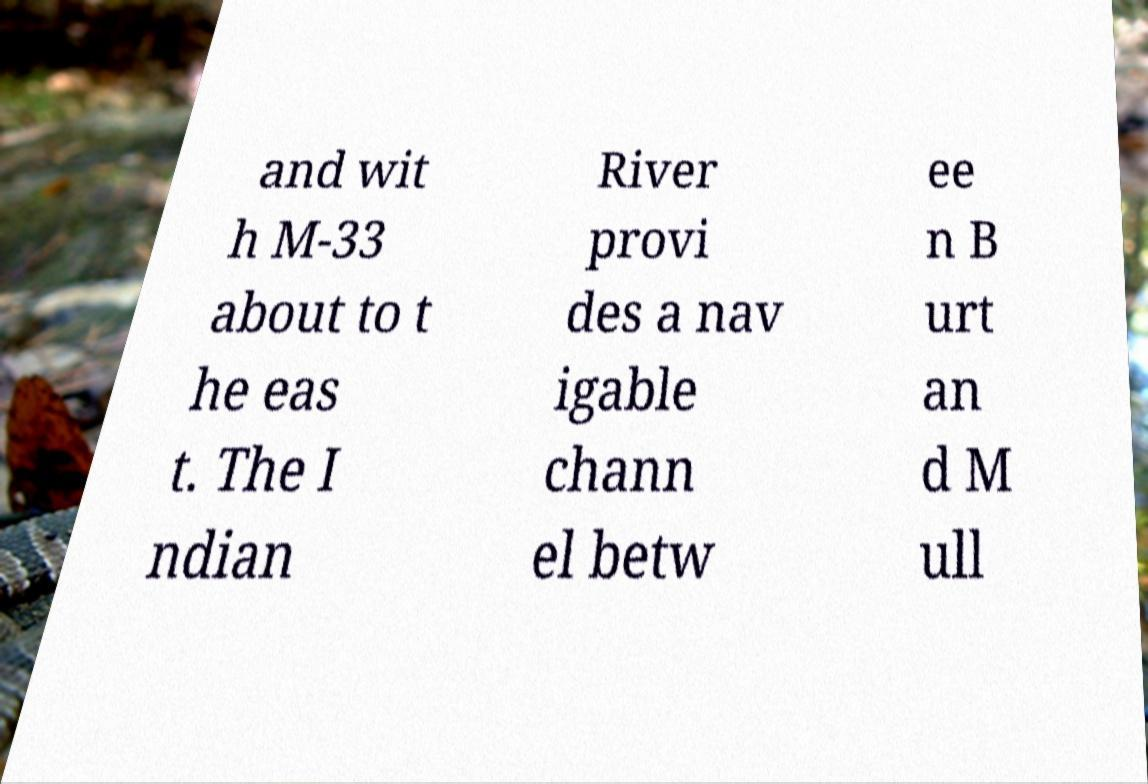Can you accurately transcribe the text from the provided image for me? and wit h M-33 about to t he eas t. The I ndian River provi des a nav igable chann el betw ee n B urt an d M ull 